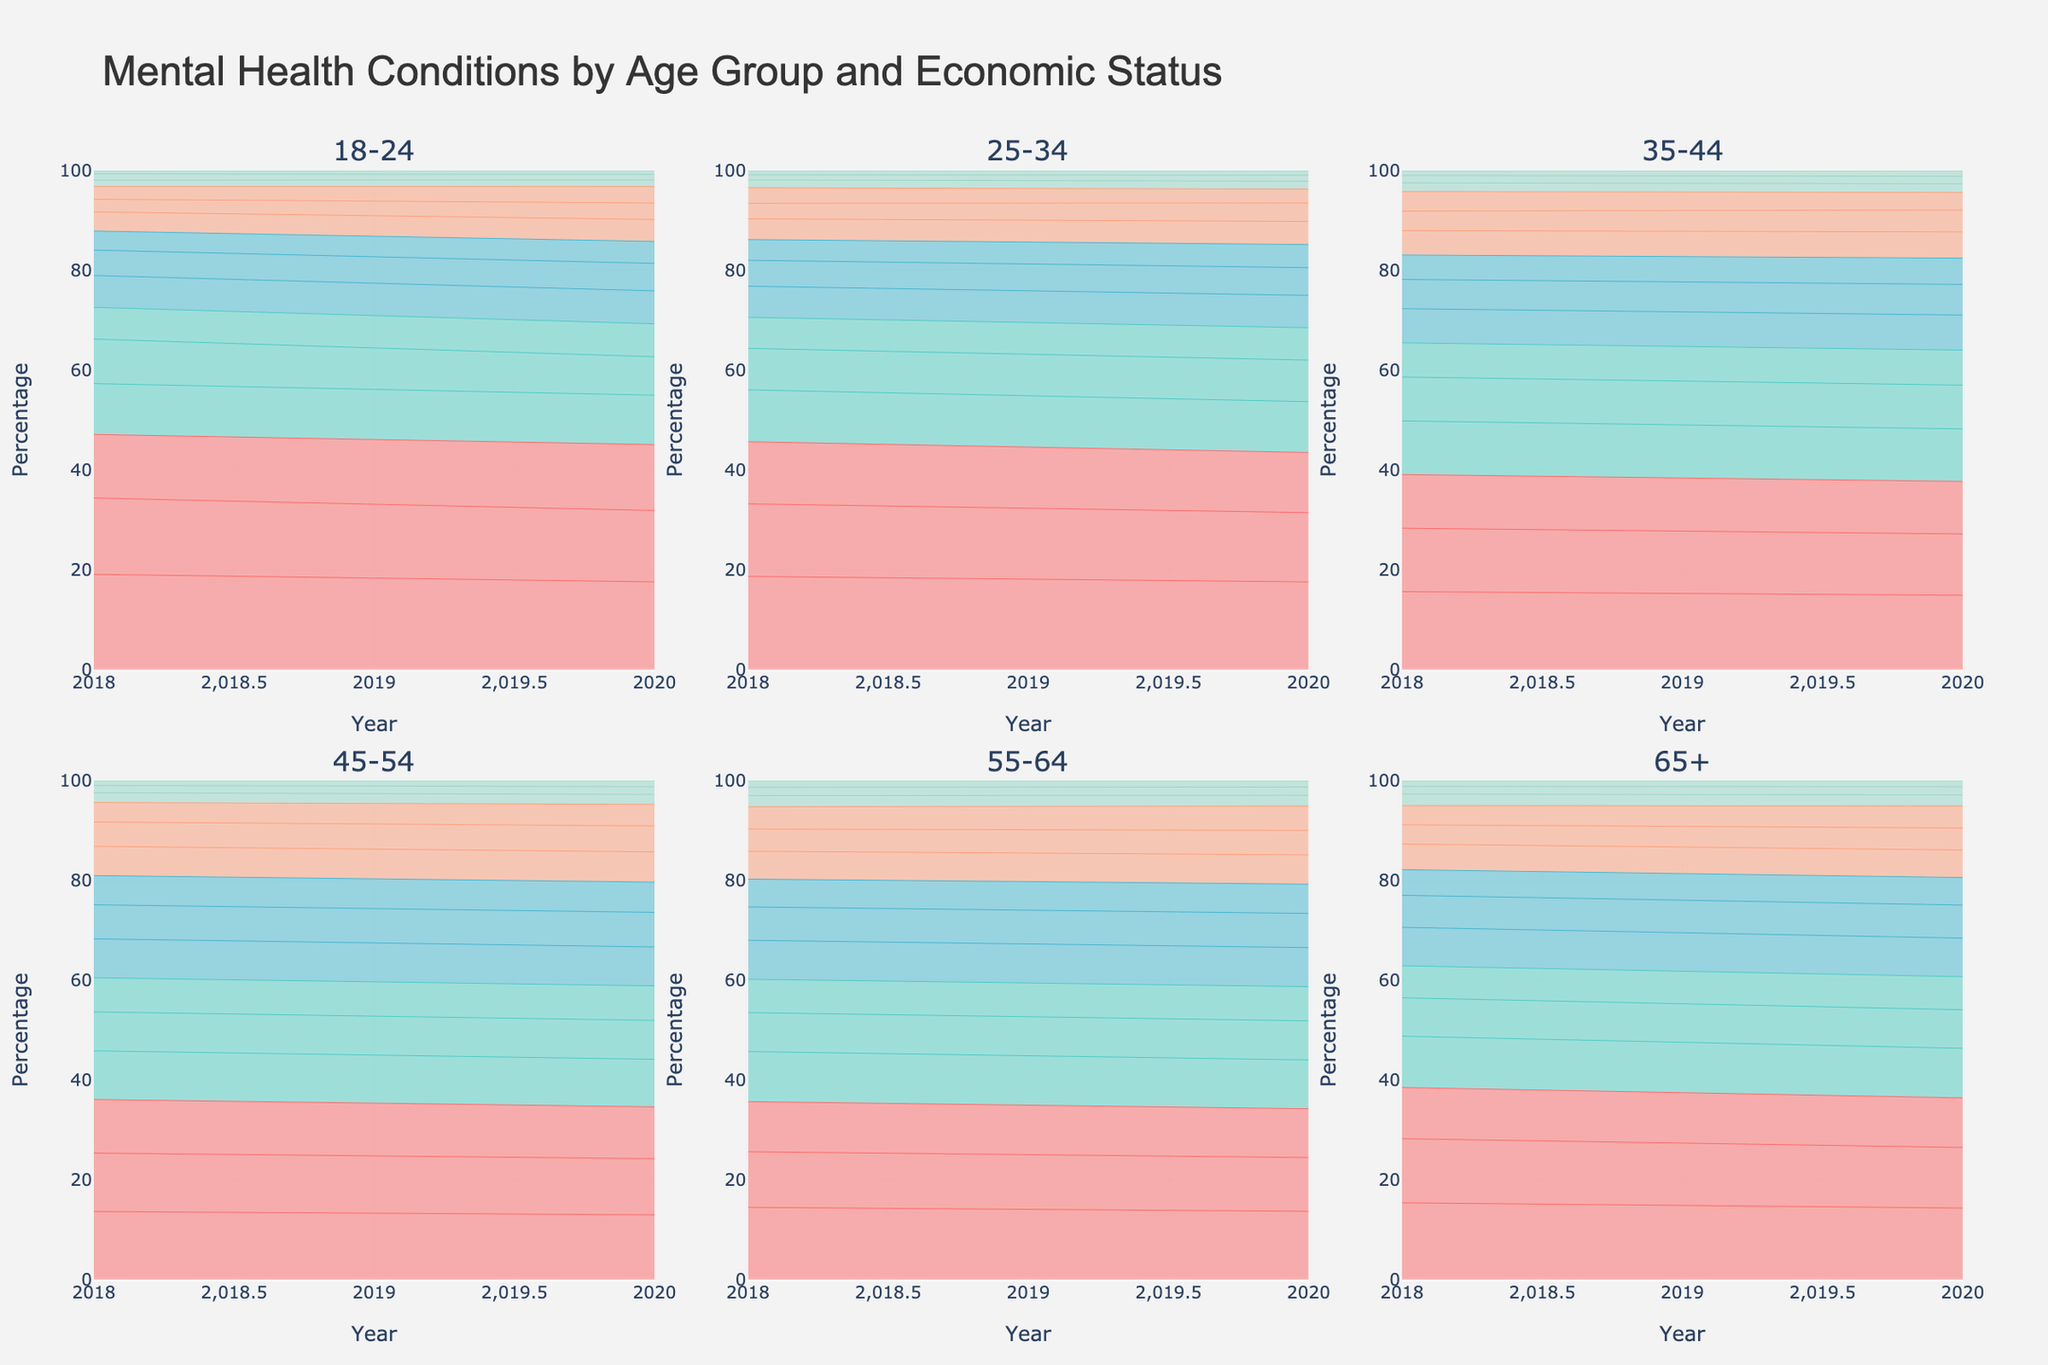What is the title of the figure? The title of the figure is displayed at the top and reads: "Mental Health Conditions by Age Group and Economic Status".
Answer: Mental Health Conditions by Age Group and Economic Status How many subplots are there within the figure? The figure includes multiple subplots for each age group. By counting the titles of the subplots, we see there are six subplots corresponding to six different age groups.
Answer: Six Which age group showed the highest increase in percentage for anxiety in the low economic status category from 2018 to 2020? The age group for the low economic status category needs to be checked across the years 2018 and 2020 for anxiety. By looking at the trend lines in the subplot, the 25-34 age group shows an increase from 18% to 19%.
Answer: 25-34 What is the shape of the data for 'bipolar' diagnoses for people aged 35-44 with high economic status? To determine the shape of the data for bipolar diagnoses within the subplot for the 35-44 age group with high economic status, one would observe the specific condition's curve. The trend shows a relatively flat line from 2018 to 2020.
Answer: Relatively flat Which economic status group has the highest percentage of mental health conditions in the age group 45-54 in 2020? By identifying the data lines in the subplot for age group 45-54 and examining the 2020 data, it can be observed that the low economic status group has the highest percentage line on the plot.
Answer: Low economic status In the age group 65+, does anxiety or depression dominate higher percentages for low economic status in 2020? By examining the subplot for the age group 65+ and comparing the lines representing anxiety and depression for the low economic status group in 2020, it is seen that anxiety has a higher percentage.
Answer: Anxiety Compare the percentage of PTSD between medium and high economic status for the age group 55-64 in 2020. Which is greater? The subplot for age group 55-64 needs to be examined for PTSD lines across medium and high economic status in the year 2020. The PTSD percentage is higher in medium economic status compared to high economic status.
Answer: Medium economic status What is the trend for schizophrenia diagnoses across all age groups in high economic status from 2018 to 2020? By looking at each subplot for high economic status and identifying the trend line for schizophrenia in each age group from 2018 to 2020, it shows generally a stable or slightly decreasing trend.
Answer: Stable or slightly decreasing What differences can be observed between the trends for depression in low economic status in 2018 and 2020 across age groups? To analyze trends for depression in low economic status, one should look at each subplot for the depression curve for low economic status and compare the years 2018 and 2020. Generally, there is an observable increase from 2018 to 2020 across almost all age groups.
Answer: Increase across most age groups Is the pattern for bipolar disorders consistent across all age groups for medium economic status? Observing the curves for bipolar disorders in medium economic status across each subplot reveals that it shows some variation; while it is relatively stable for most age groups, slight increases or decreases appear in some, indicating inconsistency.
Answer: No, it is inconsistent 